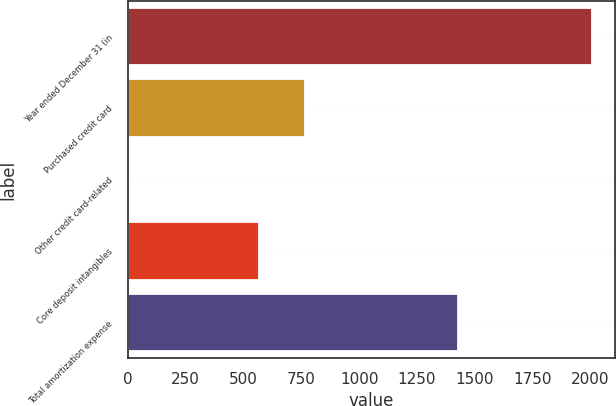Convert chart. <chart><loc_0><loc_0><loc_500><loc_500><bar_chart><fcel>Year ended December 31 (in<fcel>Purchased credit card<fcel>Other credit card-related<fcel>Core deposit intangibles<fcel>Total amortization expense<nl><fcel>2006<fcel>768<fcel>6<fcel>568<fcel>1428<nl></chart> 